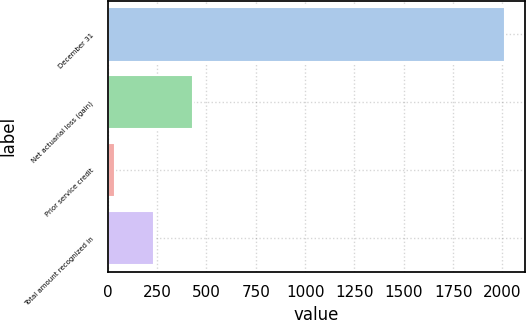Convert chart. <chart><loc_0><loc_0><loc_500><loc_500><bar_chart><fcel>December 31<fcel>Net actuarial loss (gain)<fcel>Prior service credit<fcel>Total amount recognized in<nl><fcel>2014<fcel>433.2<fcel>38<fcel>235.6<nl></chart> 